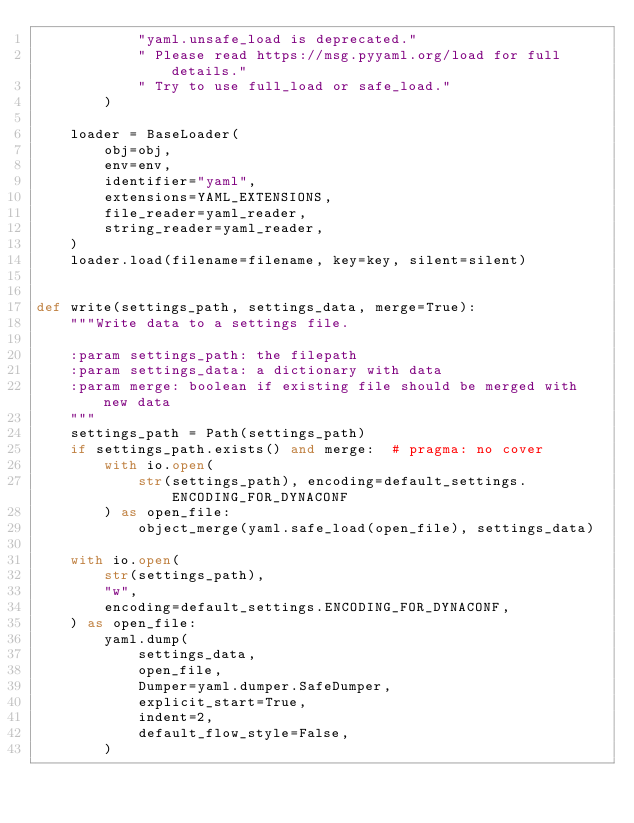Convert code to text. <code><loc_0><loc_0><loc_500><loc_500><_Python_>            "yaml.unsafe_load is deprecated."
            " Please read https://msg.pyyaml.org/load for full details."
            " Try to use full_load or safe_load."
        )

    loader = BaseLoader(
        obj=obj,
        env=env,
        identifier="yaml",
        extensions=YAML_EXTENSIONS,
        file_reader=yaml_reader,
        string_reader=yaml_reader,
    )
    loader.load(filename=filename, key=key, silent=silent)


def write(settings_path, settings_data, merge=True):
    """Write data to a settings file.

    :param settings_path: the filepath
    :param settings_data: a dictionary with data
    :param merge: boolean if existing file should be merged with new data
    """
    settings_path = Path(settings_path)
    if settings_path.exists() and merge:  # pragma: no cover
        with io.open(
            str(settings_path), encoding=default_settings.ENCODING_FOR_DYNACONF
        ) as open_file:
            object_merge(yaml.safe_load(open_file), settings_data)

    with io.open(
        str(settings_path),
        "w",
        encoding=default_settings.ENCODING_FOR_DYNACONF,
    ) as open_file:
        yaml.dump(
            settings_data,
            open_file,
            Dumper=yaml.dumper.SafeDumper,
            explicit_start=True,
            indent=2,
            default_flow_style=False,
        )
</code> 